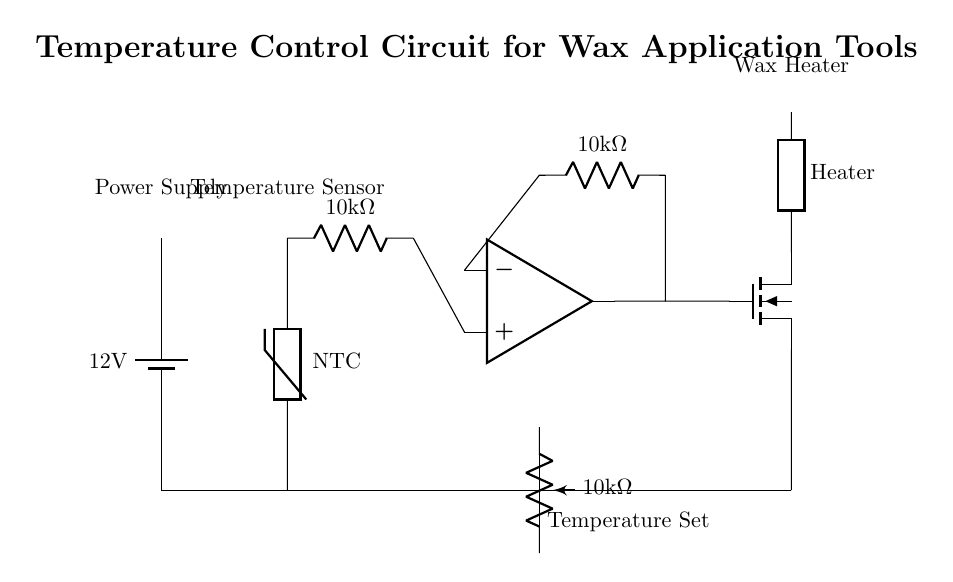What is the voltage of the power supply? The circuit shows a battery symbol that is labeled with a voltage of 12 volts, indicating the power supply voltage.
Answer: 12 volts What type of temperature sensor is used in this circuit? The diagram specifically identifies the sensor as a thermistor, labeled as "NTC," which denotes a negative temperature coefficient thermistor.
Answer: NTC thermistor What is the resistance value of the voltage divider resistor? The diagram shows a resistor labeled with a resistance value of 10 kilo-ohms, indicating the resistance used in the voltage divider configuration.
Answer: 10 kilo-ohms How does the MOSFET affect the heater? The MOSFET is used as a switch to control the current flowing to the heating element based on the control signal from the op-amp. When it is turned on, it allows current to flow through the heater, increasing its temperature.
Answer: Acts as a switch What is the function of the potentiometer in this circuit? The potentiometer is used to set the desired temperature by adjusting the resistance in the feedback loop of the op-amp, thereby controlling how much voltage is input to the op-amp depending on the temperature setting.
Answer: Temperature setting What would happen if the thermistor resistance increases? As the thermistor is an NTC type, an increase in its resistance indicates a decrease in temperature. This would result in the op-amp output changing its state, potentially increasing the duty cycle of the MOSFET to heat the wax more until the set temperature is reached.
Answer: Increased heater output 